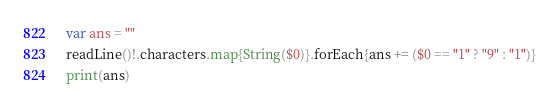Convert code to text. <code><loc_0><loc_0><loc_500><loc_500><_Swift_>var ans = ""
readLine()!.characters.map{String($0)}.forEach{ans += ($0 == "1" ? "9" : "1")}
print(ans)</code> 